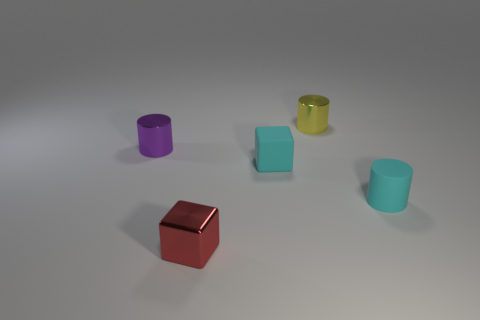Subtract all small cyan cylinders. How many cylinders are left? 2 Add 3 small shiny objects. How many objects exist? 8 Subtract all cylinders. How many objects are left? 2 Subtract all small metal cylinders. Subtract all red rubber things. How many objects are left? 3 Add 1 small yellow objects. How many small yellow objects are left? 2 Add 2 red cubes. How many red cubes exist? 3 Subtract 0 blue spheres. How many objects are left? 5 